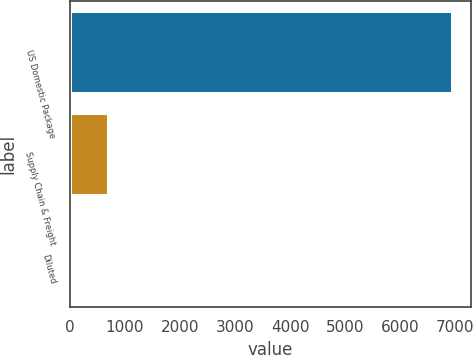Convert chart to OTSL. <chart><loc_0><loc_0><loc_500><loc_500><bar_chart><fcel>US Domestic Package<fcel>Supply Chain & Freight<fcel>Diluted<nl><fcel>6942<fcel>694.99<fcel>0.88<nl></chart> 